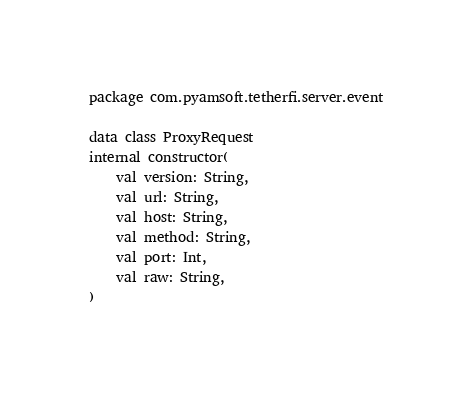<code> <loc_0><loc_0><loc_500><loc_500><_Kotlin_>package com.pyamsoft.tetherfi.server.event

data class ProxyRequest
internal constructor(
    val version: String,
    val url: String,
    val host: String,
    val method: String,
    val port: Int,
    val raw: String,
)
</code> 